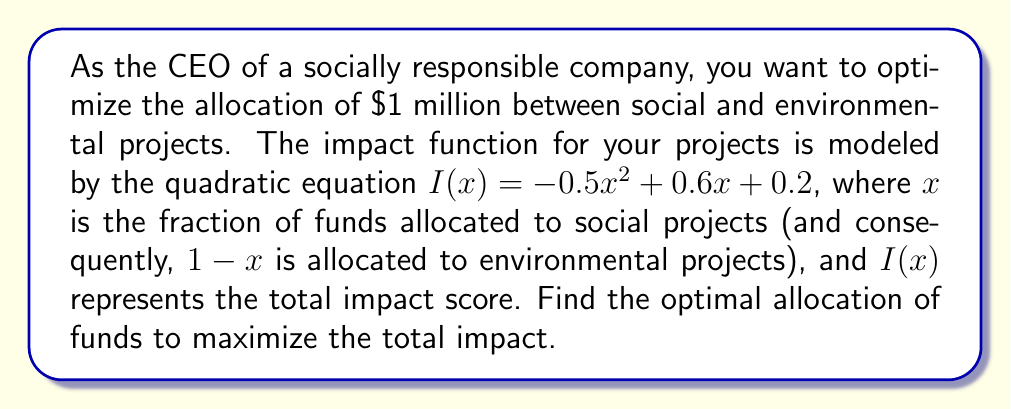Provide a solution to this math problem. To find the optimal allocation, we need to maximize the impact function $I(x)$. This can be done by finding the vertex of the parabola described by the quadratic equation.

Step 1: Identify the quadratic equation
$I(x) = -0.5x^2 + 0.6x + 0.2$

Step 2: Use the vertex formula for a quadratic equation in the form $ax^2 + bx + c$:
$x = -\frac{b}{2a}$

Here, $a = -0.5$ and $b = 0.6$

Step 3: Calculate the x-coordinate of the vertex
$x = -\frac{0.6}{2(-0.5)} = -\frac{0.6}{-1} = 0.6$

Step 4: Interpret the result
The optimal allocation is to assign 60% ($0.6 \times \$1$ million $= \$600,000$) to social projects and the remaining 40% ($\$400,000$) to environmental projects.

Step 5: Calculate the maximum impact (optional)
$I(0.6) = -0.5(0.6)^2 + 0.6(0.6) + 0.2$
$= -0.5(0.36) + 0.36 + 0.2$
$= -0.18 + 0.36 + 0.2$
$= 0.38$

The maximum impact score is 0.38.
Answer: Allocate 60% ($600,000) to social projects and 40% ($400,000) to environmental projects. 